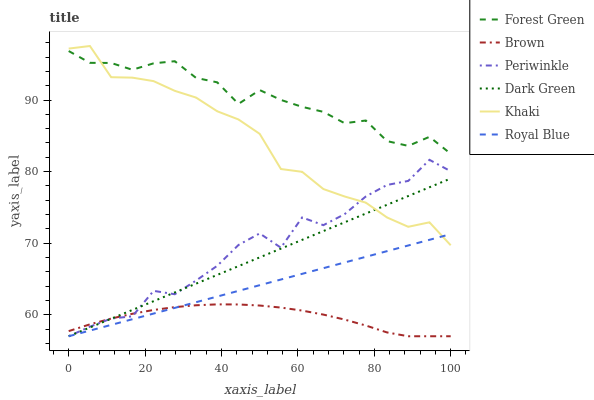Does Brown have the minimum area under the curve?
Answer yes or no. Yes. Does Forest Green have the maximum area under the curve?
Answer yes or no. Yes. Does Khaki have the minimum area under the curve?
Answer yes or no. No. Does Khaki have the maximum area under the curve?
Answer yes or no. No. Is Royal Blue the smoothest?
Answer yes or no. Yes. Is Periwinkle the roughest?
Answer yes or no. Yes. Is Khaki the smoothest?
Answer yes or no. No. Is Khaki the roughest?
Answer yes or no. No. Does Khaki have the lowest value?
Answer yes or no. No. Does Khaki have the highest value?
Answer yes or no. Yes. Does Royal Blue have the highest value?
Answer yes or no. No. Is Brown less than Forest Green?
Answer yes or no. Yes. Is Forest Green greater than Periwinkle?
Answer yes or no. Yes. Does Brown intersect Forest Green?
Answer yes or no. No. 